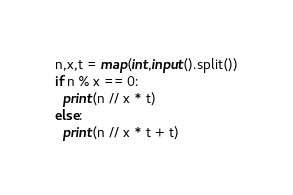Convert code to text. <code><loc_0><loc_0><loc_500><loc_500><_Python_>n,x,t = map(int,input().split())
if n % x == 0:
  print(n // x * t)
else:
  print(n // x * t + t)</code> 